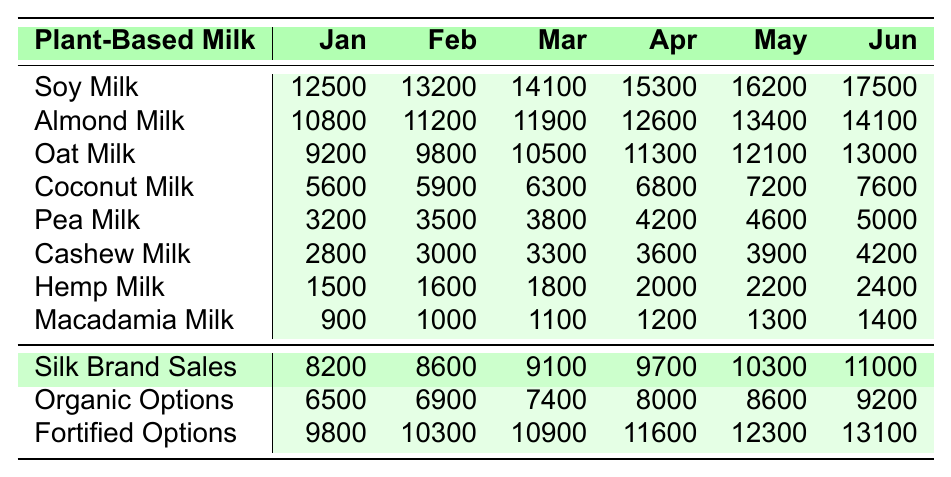What was the total sales of Soy Milk in June? Looking at the table, the sales of Soy Milk in June is listed as 17500. Therefore, no calculations are necessary.
Answer: 17500 Which plant-based milk had the highest sales in April? In April, the sales values for each type of milk were: Soy Milk (15300), Almond Milk (12600), Oat Milk (11300), Coconut Milk (6800), Pea Milk (4200), Cashew Milk (3600), Hemp Milk (2000), and Macadamia Milk (1200). The highest value among these is for Soy Milk.
Answer: Soy Milk What is the average sales of Coconut Milk from January to June? The sales values for Coconut Milk from January to June are: 5600, 5900, 6300, 6800, 7200, and 7600. To find the average, we sum these values: 5600 + 5900 + 6300 + 6800 + 7200 + 7600 = 39600. Then, we divide by the number of months (6): 39600 / 6 = 6600.
Answer: 6600 Did the sales of Pea Milk increase every month? The sales of Pea Milk for each month are: 3200 (Jan), 3500 (Feb), 3800 (Mar), 4200 (Apr), 4600 (May), and 5000 (Jun). Each month has a higher value than the previous, indicating a consistent increase.
Answer: Yes What was the total sales of all plant-based milks combined in May? To find the total sales in May, we sum the values for each type of milk: Soy (16200), Almond (13400), Oat (12100), Coconut (7200), Pea (4600), Cashew (3900), Hemp (2200), Macadamia (1300). Thus, total = 16200 + 13400 + 12100 + 7200 + 4600 + 3900 + 2200 + 1300 = 60000.
Answer: 60000 Which milk type saw the smallest sales in January? From the table, the sales in January are: Soy Milk (12500), Almond Milk (10800), Oat Milk (9200), Coconut Milk (5600), Pea Milk (3200), Cashew Milk (2800), Hemp Milk (1500), and Macadamia Milk (900). The smallest value is for Macadamia Milk.
Answer: Macadamia Milk What percentage increase in sales did Oat Milk see from January to June? The sales of Oat Milk in January is 9200 and in June is 13000. First, calculate the increase: 13000 - 9200 = 3800. Next, compute the percentage increase: (3800 / 9200) * 100 = 41.3%.
Answer: 41.3% How much more did Silk Brand Sales total in June compared to the sales of Hemp Milk in the same month? The sales for Silk Brand in June is 11000 and for Hemp Milk is 2400. The difference is calculated as 11000 - 2400 = 8600.
Answer: 8600 Which month had the highest sales for Organic Options? Looking through the data, the values for Organic Options from January to June are: 6500, 6900, 7400, 8000, 8600, and 9200. June has the highest value of 9200.
Answer: June In terms of total sales from January to June, how does Almond Milk compare to Fortified Options? The total sales for Almond Milk are calculated as: 10800 + 11200 + 11900 + 12600 + 13400 + 14100 = 74000. For Fortified Options, the total is: 9800 + 10300 + 10900 + 11600 + 12300 + 13100 = 66000. Comparing both totals, Almond Milk (74000) is higher than Fortified Options (66000).
Answer: Almond Milk is higher 